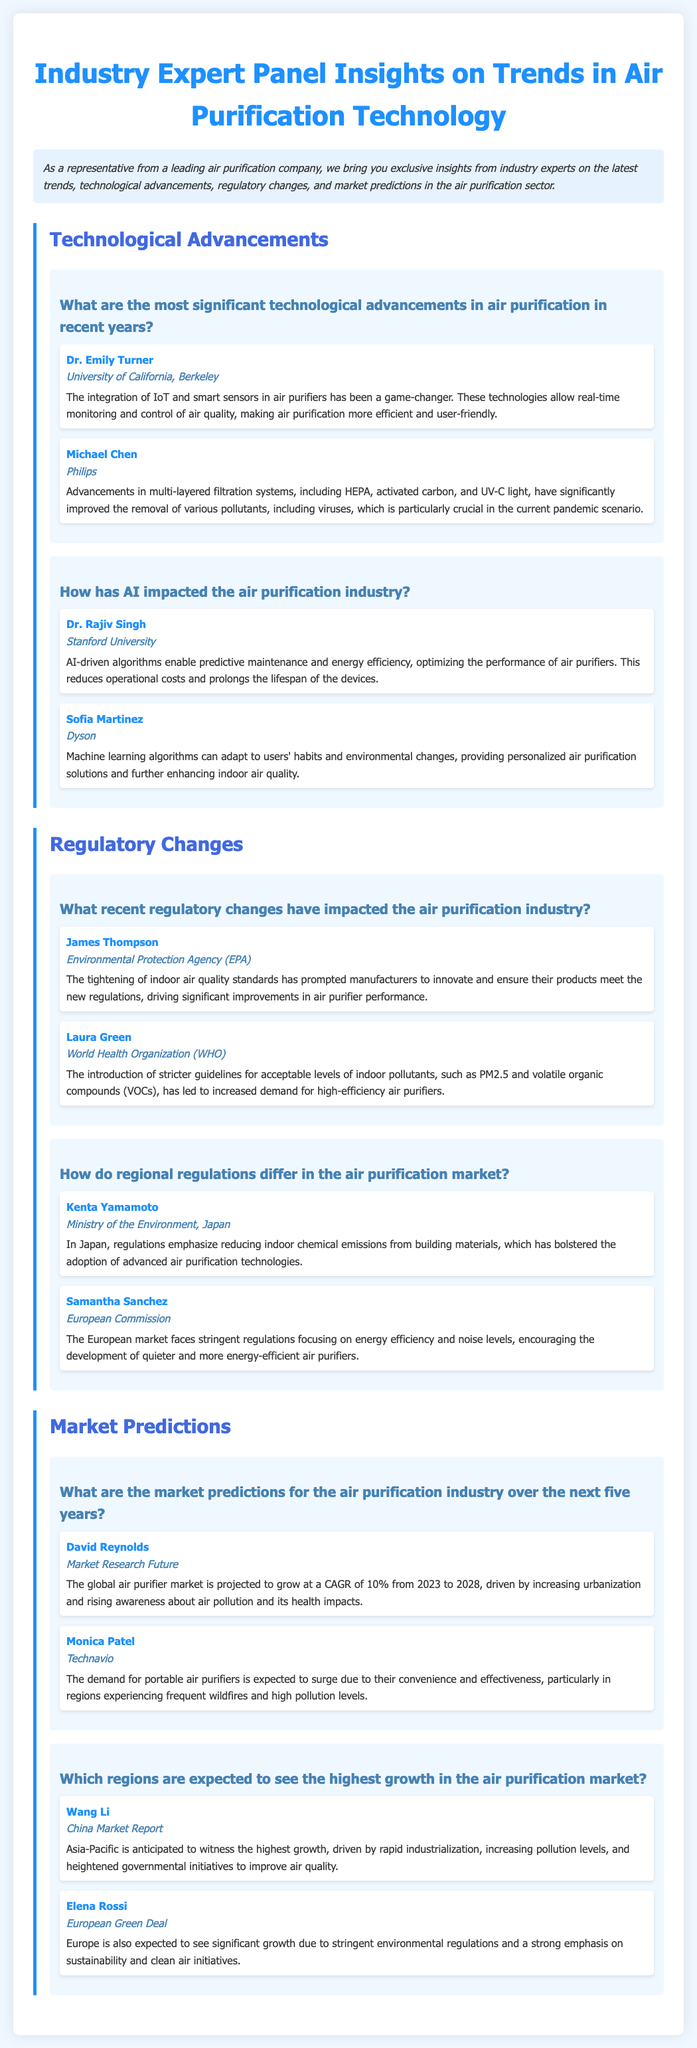What is the primary focus of the document? The document provides insights from industry experts on trends, technological advancements, regulatory changes, and market predictions in air purification technology.
Answer: Air purification technology Who provided insights on AI's impact in the air purification industry? The document lists experts who contributed insights, including Dr. Rajiv Singh and Sofia Martinez, discussing AI's role.
Answer: Dr. Rajiv Singh, Sofia Martinez What is the projected CAGR of the global air purifier market from 2023 to 2028? The document states the growth rate of the air purifier market as a compound annual growth rate (CAGR) of 10% from 2023 to 2028.
Answer: 10% Which organization mentioned tightening indoor air quality standards? The document references James Thompson from the Environmental Protection Agency (EPA) discussing the tightening of standards.
Answer: Environmental Protection Agency (EPA) What trend is expected to increase demand for portable air purifiers? The document notes that convenience and effectiveness, particularly in regions with high pollution and wildfires, will drive demand.
Answer: Convenience and effectiveness What region is anticipated to have the highest growth in the air purification market? The document indicates that Asia-Pacific is expected to witness the highest growth in the air purification market.
Answer: Asia-Pacific What recent regulatory change has influenced air purifier performance? The document mentions the tightening of indoor air quality standards prompting manufacturers to innovate products.
Answer: Tightening of indoor air quality standards Which filter combination is mentioned as significant in improving pollutant removal? The experts provide insight on multi-layered filtration systems that include HEPA, activated carbon, and UV-C light.
Answer: HEPA, activated carbon, and UV-C light 